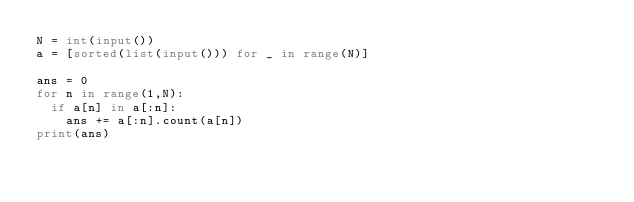<code> <loc_0><loc_0><loc_500><loc_500><_Python_>N = int(input())
a = [sorted(list(input())) for _ in range(N)]

ans = 0
for n in range(1,N):
  if a[n] in a[:n]:
    ans += a[:n].count(a[n])
print(ans)</code> 